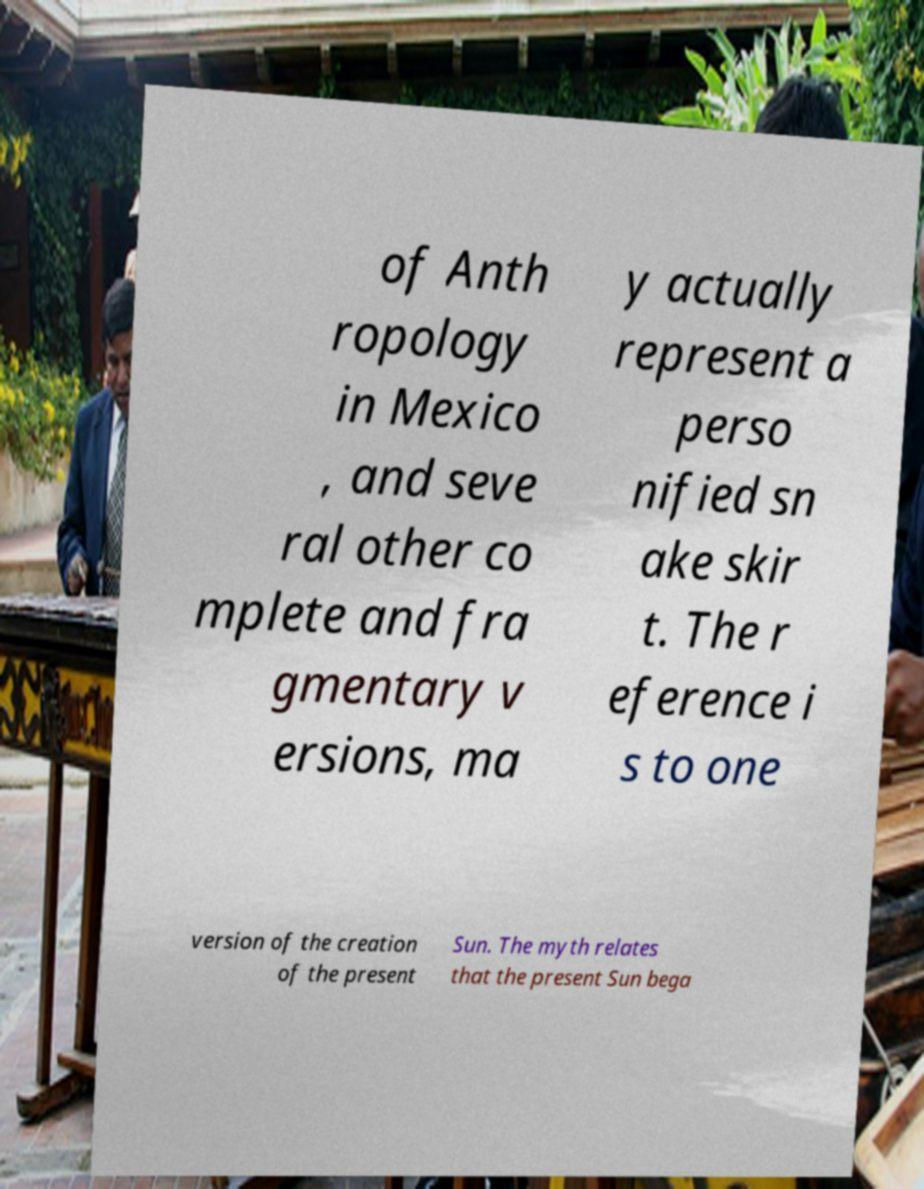Can you accurately transcribe the text from the provided image for me? of Anth ropology in Mexico , and seve ral other co mplete and fra gmentary v ersions, ma y actually represent a perso nified sn ake skir t. The r eference i s to one version of the creation of the present Sun. The myth relates that the present Sun bega 